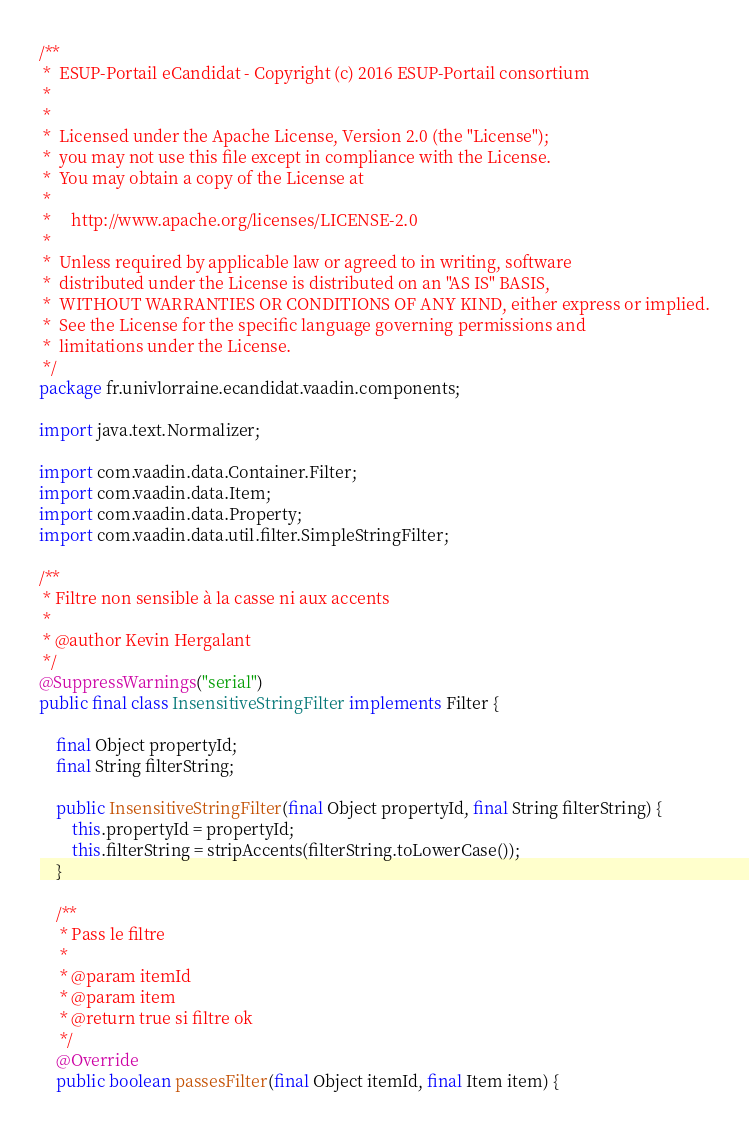<code> <loc_0><loc_0><loc_500><loc_500><_Java_>/**
 *  ESUP-Portail eCandidat - Copyright (c) 2016 ESUP-Portail consortium
 *
 *
 *  Licensed under the Apache License, Version 2.0 (the "License");
 *  you may not use this file except in compliance with the License.
 *  You may obtain a copy of the License at
 *
 *     http://www.apache.org/licenses/LICENSE-2.0
 *
 *  Unless required by applicable law or agreed to in writing, software
 *  distributed under the License is distributed on an "AS IS" BASIS,
 *  WITHOUT WARRANTIES OR CONDITIONS OF ANY KIND, either express or implied.
 *  See the License for the specific language governing permissions and
 *  limitations under the License.
 */
package fr.univlorraine.ecandidat.vaadin.components;

import java.text.Normalizer;

import com.vaadin.data.Container.Filter;
import com.vaadin.data.Item;
import com.vaadin.data.Property;
import com.vaadin.data.util.filter.SimpleStringFilter;

/**
 * Filtre non sensible à la casse ni aux accents
 *
 * @author Kevin Hergalant
 */
@SuppressWarnings("serial")
public final class InsensitiveStringFilter implements Filter {

	final Object propertyId;
	final String filterString;

	public InsensitiveStringFilter(final Object propertyId, final String filterString) {
		this.propertyId = propertyId;
		this.filterString = stripAccents(filterString.toLowerCase());
	}

	/**
	 * Pass le filtre
	 *
	 * @param itemId
	 * @param item
	 * @return true si filtre ok
	 */
	@Override
	public boolean passesFilter(final Object itemId, final Item item) {</code> 